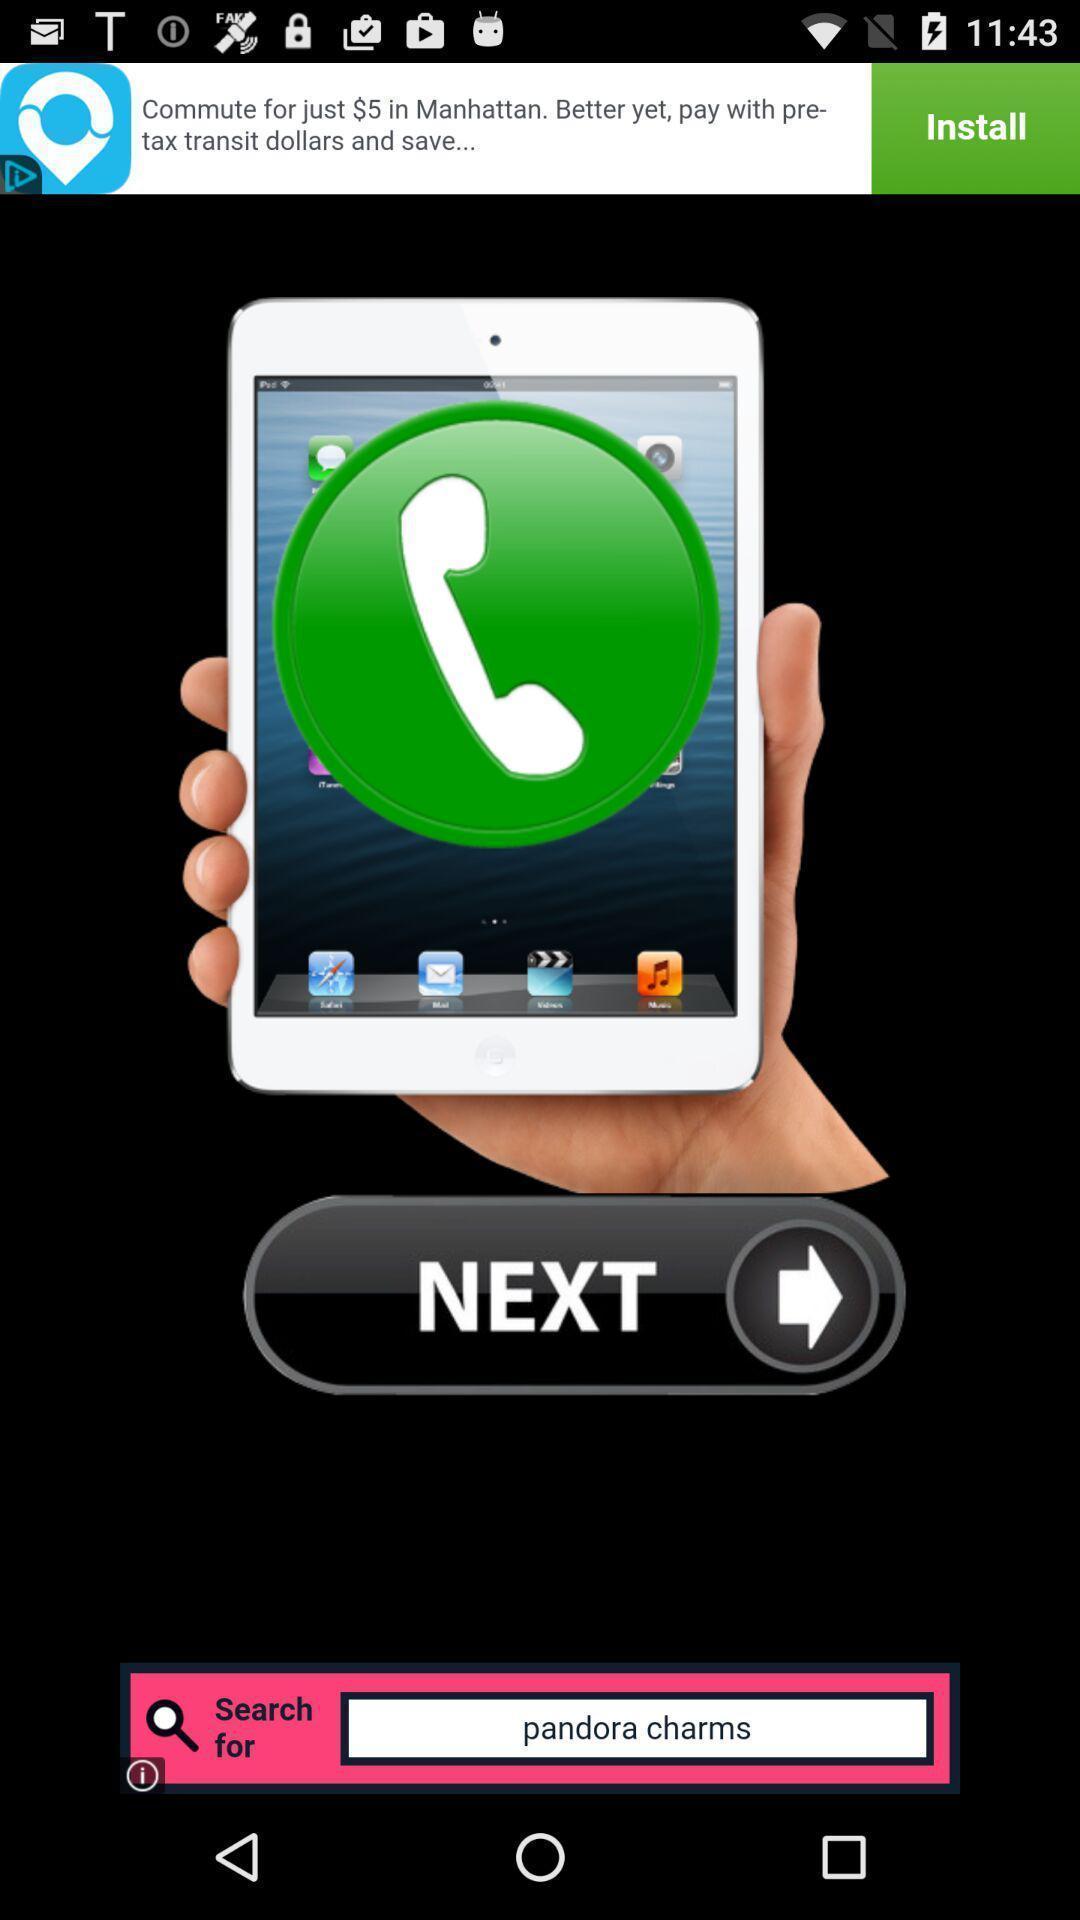Summarize the main components in this picture. Welcome page displayed. 